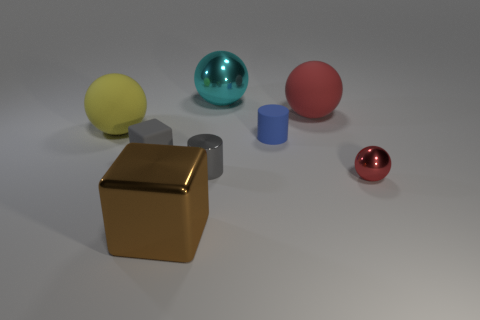Add 2 small red metal cylinders. How many objects exist? 10 Subtract all cubes. How many objects are left? 6 Add 3 large brown metal blocks. How many large brown metal blocks are left? 4 Add 1 cubes. How many cubes exist? 3 Subtract 0 blue balls. How many objects are left? 8 Subtract all large red balls. Subtract all tiny spheres. How many objects are left? 6 